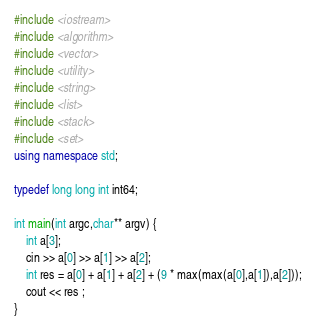Convert code to text. <code><loc_0><loc_0><loc_500><loc_500><_C++_>#include <iostream>
#include <algorithm>
#include <vector>
#include <utility>
#include <string>
#include <list>
#include <stack>
#include <set>
using namespace std;

typedef long long int int64;

int main(int argc,char** argv) {
    int a[3];
    cin >> a[0] >> a[1] >> a[2];
    int res = a[0] + a[1] + a[2] + (9 * max(max(a[0],a[1]),a[2]));
    cout << res ;
}
</code> 